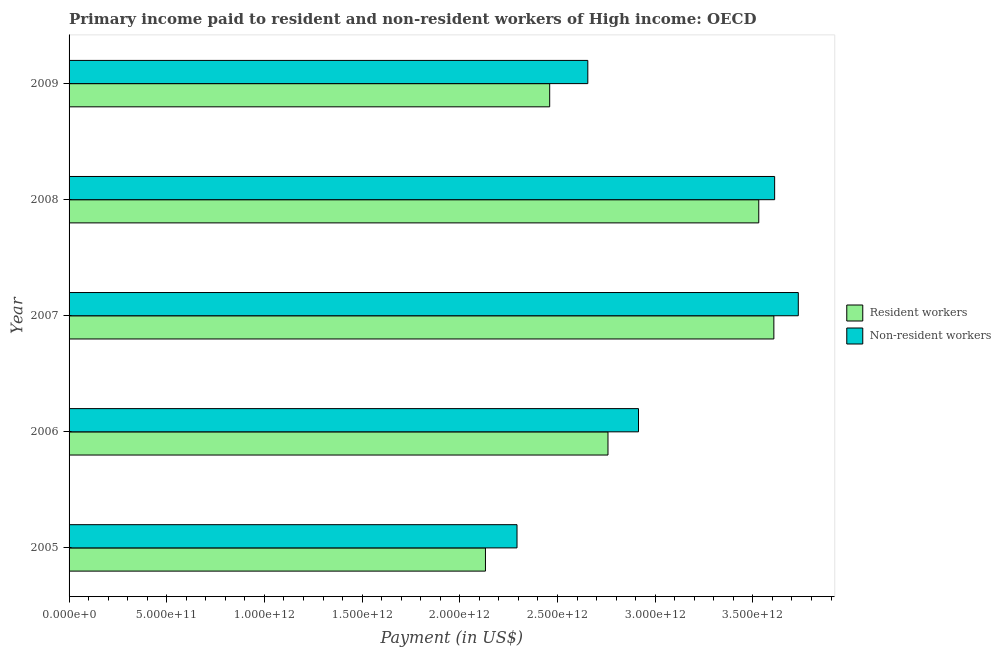Are the number of bars per tick equal to the number of legend labels?
Your answer should be very brief. Yes. What is the payment made to resident workers in 2005?
Your answer should be very brief. 2.13e+12. Across all years, what is the maximum payment made to resident workers?
Provide a succinct answer. 3.61e+12. Across all years, what is the minimum payment made to resident workers?
Keep it short and to the point. 2.13e+12. In which year was the payment made to non-resident workers maximum?
Keep it short and to the point. 2007. What is the total payment made to resident workers in the graph?
Your answer should be very brief. 1.45e+13. What is the difference between the payment made to non-resident workers in 2006 and that in 2009?
Offer a very short reply. 2.59e+11. What is the difference between the payment made to non-resident workers in 2009 and the payment made to resident workers in 2006?
Your answer should be very brief. -1.03e+11. What is the average payment made to resident workers per year?
Provide a succinct answer. 2.90e+12. In the year 2008, what is the difference between the payment made to non-resident workers and payment made to resident workers?
Provide a succinct answer. 8.13e+1. What is the ratio of the payment made to non-resident workers in 2007 to that in 2008?
Your answer should be very brief. 1.03. Is the payment made to non-resident workers in 2008 less than that in 2009?
Keep it short and to the point. No. Is the difference between the payment made to non-resident workers in 2007 and 2009 greater than the difference between the payment made to resident workers in 2007 and 2009?
Your response must be concise. No. What is the difference between the highest and the second highest payment made to non-resident workers?
Keep it short and to the point. 1.21e+11. What is the difference between the highest and the lowest payment made to non-resident workers?
Your answer should be compact. 1.44e+12. In how many years, is the payment made to non-resident workers greater than the average payment made to non-resident workers taken over all years?
Keep it short and to the point. 2. What does the 2nd bar from the top in 2008 represents?
Ensure brevity in your answer.  Resident workers. What does the 2nd bar from the bottom in 2006 represents?
Provide a short and direct response. Non-resident workers. How many bars are there?
Ensure brevity in your answer.  10. What is the difference between two consecutive major ticks on the X-axis?
Ensure brevity in your answer.  5.00e+11. Where does the legend appear in the graph?
Ensure brevity in your answer.  Center right. How are the legend labels stacked?
Offer a terse response. Vertical. What is the title of the graph?
Make the answer very short. Primary income paid to resident and non-resident workers of High income: OECD. What is the label or title of the X-axis?
Offer a very short reply. Payment (in US$). What is the label or title of the Y-axis?
Your answer should be very brief. Year. What is the Payment (in US$) of Resident workers in 2005?
Offer a very short reply. 2.13e+12. What is the Payment (in US$) of Non-resident workers in 2005?
Your answer should be very brief. 2.29e+12. What is the Payment (in US$) of Resident workers in 2006?
Give a very brief answer. 2.76e+12. What is the Payment (in US$) of Non-resident workers in 2006?
Keep it short and to the point. 2.91e+12. What is the Payment (in US$) of Resident workers in 2007?
Your answer should be very brief. 3.61e+12. What is the Payment (in US$) of Non-resident workers in 2007?
Give a very brief answer. 3.73e+12. What is the Payment (in US$) in Resident workers in 2008?
Provide a succinct answer. 3.53e+12. What is the Payment (in US$) of Non-resident workers in 2008?
Your response must be concise. 3.61e+12. What is the Payment (in US$) in Resident workers in 2009?
Keep it short and to the point. 2.46e+12. What is the Payment (in US$) of Non-resident workers in 2009?
Offer a very short reply. 2.66e+12. Across all years, what is the maximum Payment (in US$) in Resident workers?
Provide a succinct answer. 3.61e+12. Across all years, what is the maximum Payment (in US$) in Non-resident workers?
Offer a terse response. 3.73e+12. Across all years, what is the minimum Payment (in US$) in Resident workers?
Provide a short and direct response. 2.13e+12. Across all years, what is the minimum Payment (in US$) of Non-resident workers?
Provide a succinct answer. 2.29e+12. What is the total Payment (in US$) in Resident workers in the graph?
Offer a terse response. 1.45e+13. What is the total Payment (in US$) of Non-resident workers in the graph?
Ensure brevity in your answer.  1.52e+13. What is the difference between the Payment (in US$) of Resident workers in 2005 and that in 2006?
Offer a terse response. -6.27e+11. What is the difference between the Payment (in US$) in Non-resident workers in 2005 and that in 2006?
Give a very brief answer. -6.22e+11. What is the difference between the Payment (in US$) in Resident workers in 2005 and that in 2007?
Provide a succinct answer. -1.48e+12. What is the difference between the Payment (in US$) of Non-resident workers in 2005 and that in 2007?
Ensure brevity in your answer.  -1.44e+12. What is the difference between the Payment (in US$) in Resident workers in 2005 and that in 2008?
Your answer should be very brief. -1.40e+12. What is the difference between the Payment (in US$) in Non-resident workers in 2005 and that in 2008?
Your answer should be compact. -1.32e+12. What is the difference between the Payment (in US$) in Resident workers in 2005 and that in 2009?
Your answer should be very brief. -3.29e+11. What is the difference between the Payment (in US$) in Non-resident workers in 2005 and that in 2009?
Provide a succinct answer. -3.62e+11. What is the difference between the Payment (in US$) of Resident workers in 2006 and that in 2007?
Offer a very short reply. -8.49e+11. What is the difference between the Payment (in US$) in Non-resident workers in 2006 and that in 2007?
Give a very brief answer. -8.18e+11. What is the difference between the Payment (in US$) in Resident workers in 2006 and that in 2008?
Keep it short and to the point. -7.72e+11. What is the difference between the Payment (in US$) in Non-resident workers in 2006 and that in 2008?
Give a very brief answer. -6.97e+11. What is the difference between the Payment (in US$) of Resident workers in 2006 and that in 2009?
Offer a terse response. 2.98e+11. What is the difference between the Payment (in US$) in Non-resident workers in 2006 and that in 2009?
Give a very brief answer. 2.59e+11. What is the difference between the Payment (in US$) in Resident workers in 2007 and that in 2008?
Offer a very short reply. 7.73e+1. What is the difference between the Payment (in US$) of Non-resident workers in 2007 and that in 2008?
Your answer should be compact. 1.21e+11. What is the difference between the Payment (in US$) of Resident workers in 2007 and that in 2009?
Give a very brief answer. 1.15e+12. What is the difference between the Payment (in US$) in Non-resident workers in 2007 and that in 2009?
Provide a succinct answer. 1.08e+12. What is the difference between the Payment (in US$) of Resident workers in 2008 and that in 2009?
Your answer should be compact. 1.07e+12. What is the difference between the Payment (in US$) in Non-resident workers in 2008 and that in 2009?
Make the answer very short. 9.56e+11. What is the difference between the Payment (in US$) in Resident workers in 2005 and the Payment (in US$) in Non-resident workers in 2006?
Ensure brevity in your answer.  -7.83e+11. What is the difference between the Payment (in US$) in Resident workers in 2005 and the Payment (in US$) in Non-resident workers in 2007?
Keep it short and to the point. -1.60e+12. What is the difference between the Payment (in US$) of Resident workers in 2005 and the Payment (in US$) of Non-resident workers in 2008?
Keep it short and to the point. -1.48e+12. What is the difference between the Payment (in US$) of Resident workers in 2005 and the Payment (in US$) of Non-resident workers in 2009?
Provide a succinct answer. -5.24e+11. What is the difference between the Payment (in US$) in Resident workers in 2006 and the Payment (in US$) in Non-resident workers in 2007?
Your response must be concise. -9.74e+11. What is the difference between the Payment (in US$) of Resident workers in 2006 and the Payment (in US$) of Non-resident workers in 2008?
Keep it short and to the point. -8.53e+11. What is the difference between the Payment (in US$) in Resident workers in 2006 and the Payment (in US$) in Non-resident workers in 2009?
Provide a succinct answer. 1.03e+11. What is the difference between the Payment (in US$) in Resident workers in 2007 and the Payment (in US$) in Non-resident workers in 2008?
Offer a very short reply. -4.02e+09. What is the difference between the Payment (in US$) of Resident workers in 2007 and the Payment (in US$) of Non-resident workers in 2009?
Provide a succinct answer. 9.52e+11. What is the difference between the Payment (in US$) in Resident workers in 2008 and the Payment (in US$) in Non-resident workers in 2009?
Give a very brief answer. 8.75e+11. What is the average Payment (in US$) in Resident workers per year?
Offer a terse response. 2.90e+12. What is the average Payment (in US$) in Non-resident workers per year?
Offer a very short reply. 3.04e+12. In the year 2005, what is the difference between the Payment (in US$) in Resident workers and Payment (in US$) in Non-resident workers?
Your answer should be compact. -1.62e+11. In the year 2006, what is the difference between the Payment (in US$) in Resident workers and Payment (in US$) in Non-resident workers?
Keep it short and to the point. -1.56e+11. In the year 2007, what is the difference between the Payment (in US$) of Resident workers and Payment (in US$) of Non-resident workers?
Your response must be concise. -1.25e+11. In the year 2008, what is the difference between the Payment (in US$) in Resident workers and Payment (in US$) in Non-resident workers?
Provide a succinct answer. -8.13e+1. In the year 2009, what is the difference between the Payment (in US$) in Resident workers and Payment (in US$) in Non-resident workers?
Your answer should be compact. -1.95e+11. What is the ratio of the Payment (in US$) in Resident workers in 2005 to that in 2006?
Your response must be concise. 0.77. What is the ratio of the Payment (in US$) of Non-resident workers in 2005 to that in 2006?
Your answer should be compact. 0.79. What is the ratio of the Payment (in US$) in Resident workers in 2005 to that in 2007?
Your response must be concise. 0.59. What is the ratio of the Payment (in US$) of Non-resident workers in 2005 to that in 2007?
Keep it short and to the point. 0.61. What is the ratio of the Payment (in US$) in Resident workers in 2005 to that in 2008?
Offer a very short reply. 0.6. What is the ratio of the Payment (in US$) in Non-resident workers in 2005 to that in 2008?
Provide a short and direct response. 0.63. What is the ratio of the Payment (in US$) in Resident workers in 2005 to that in 2009?
Your response must be concise. 0.87. What is the ratio of the Payment (in US$) of Non-resident workers in 2005 to that in 2009?
Provide a short and direct response. 0.86. What is the ratio of the Payment (in US$) in Resident workers in 2006 to that in 2007?
Offer a very short reply. 0.76. What is the ratio of the Payment (in US$) of Non-resident workers in 2006 to that in 2007?
Your answer should be compact. 0.78. What is the ratio of the Payment (in US$) of Resident workers in 2006 to that in 2008?
Your answer should be very brief. 0.78. What is the ratio of the Payment (in US$) of Non-resident workers in 2006 to that in 2008?
Provide a short and direct response. 0.81. What is the ratio of the Payment (in US$) in Resident workers in 2006 to that in 2009?
Provide a short and direct response. 1.12. What is the ratio of the Payment (in US$) of Non-resident workers in 2006 to that in 2009?
Provide a succinct answer. 1.1. What is the ratio of the Payment (in US$) in Resident workers in 2007 to that in 2008?
Your answer should be very brief. 1.02. What is the ratio of the Payment (in US$) in Non-resident workers in 2007 to that in 2008?
Provide a succinct answer. 1.03. What is the ratio of the Payment (in US$) in Resident workers in 2007 to that in 2009?
Offer a terse response. 1.47. What is the ratio of the Payment (in US$) in Non-resident workers in 2007 to that in 2009?
Your response must be concise. 1.41. What is the ratio of the Payment (in US$) of Resident workers in 2008 to that in 2009?
Keep it short and to the point. 1.44. What is the ratio of the Payment (in US$) in Non-resident workers in 2008 to that in 2009?
Your answer should be very brief. 1.36. What is the difference between the highest and the second highest Payment (in US$) in Resident workers?
Offer a very short reply. 7.73e+1. What is the difference between the highest and the second highest Payment (in US$) in Non-resident workers?
Give a very brief answer. 1.21e+11. What is the difference between the highest and the lowest Payment (in US$) in Resident workers?
Ensure brevity in your answer.  1.48e+12. What is the difference between the highest and the lowest Payment (in US$) in Non-resident workers?
Give a very brief answer. 1.44e+12. 